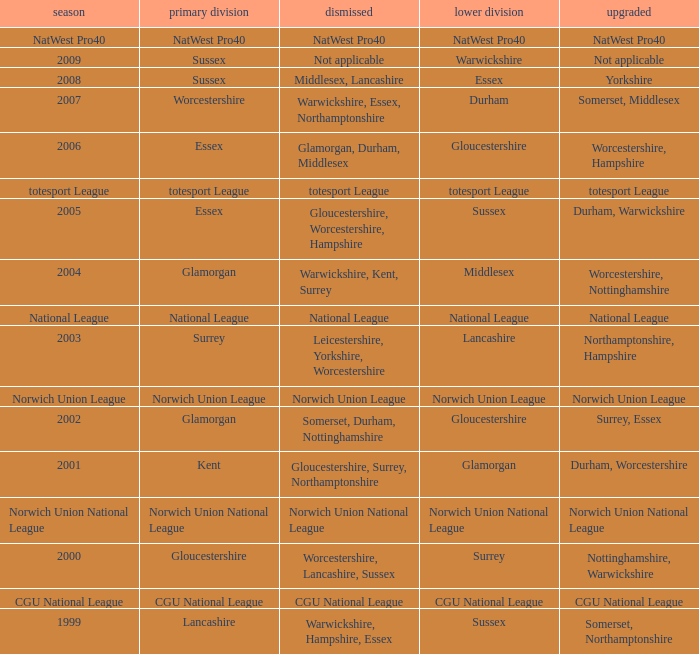What season was Norwich Union League promoted? Norwich Union League. Parse the table in full. {'header': ['season', 'primary division', 'dismissed', 'lower division', 'upgraded'], 'rows': [['NatWest Pro40', 'NatWest Pro40', 'NatWest Pro40', 'NatWest Pro40', 'NatWest Pro40'], ['2009', 'Sussex', 'Not applicable', 'Warwickshire', 'Not applicable'], ['2008', 'Sussex', 'Middlesex, Lancashire', 'Essex', 'Yorkshire'], ['2007', 'Worcestershire', 'Warwickshire, Essex, Northamptonshire', 'Durham', 'Somerset, Middlesex'], ['2006', 'Essex', 'Glamorgan, Durham, Middlesex', 'Gloucestershire', 'Worcestershire, Hampshire'], ['totesport League', 'totesport League', 'totesport League', 'totesport League', 'totesport League'], ['2005', 'Essex', 'Gloucestershire, Worcestershire, Hampshire', 'Sussex', 'Durham, Warwickshire'], ['2004', 'Glamorgan', 'Warwickshire, Kent, Surrey', 'Middlesex', 'Worcestershire, Nottinghamshire'], ['National League', 'National League', 'National League', 'National League', 'National League'], ['2003', 'Surrey', 'Leicestershire, Yorkshire, Worcestershire', 'Lancashire', 'Northamptonshire, Hampshire'], ['Norwich Union League', 'Norwich Union League', 'Norwich Union League', 'Norwich Union League', 'Norwich Union League'], ['2002', 'Glamorgan', 'Somerset, Durham, Nottinghamshire', 'Gloucestershire', 'Surrey, Essex'], ['2001', 'Kent', 'Gloucestershire, Surrey, Northamptonshire', 'Glamorgan', 'Durham, Worcestershire'], ['Norwich Union National League', 'Norwich Union National League', 'Norwich Union National League', 'Norwich Union National League', 'Norwich Union National League'], ['2000', 'Gloucestershire', 'Worcestershire, Lancashire, Sussex', 'Surrey', 'Nottinghamshire, Warwickshire'], ['CGU National League', 'CGU National League', 'CGU National League', 'CGU National League', 'CGU National League'], ['1999', 'Lancashire', 'Warwickshire, Hampshire, Essex', 'Sussex', 'Somerset, Northamptonshire']]} 